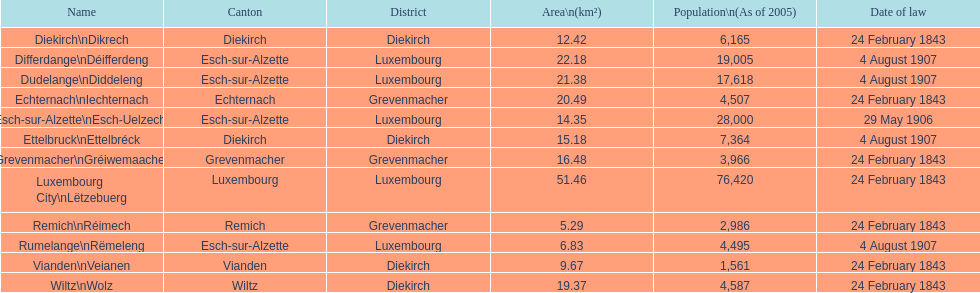Which canton falls under the date of law of 24 february 1843 and has a population of 3,966? Grevenmacher. 